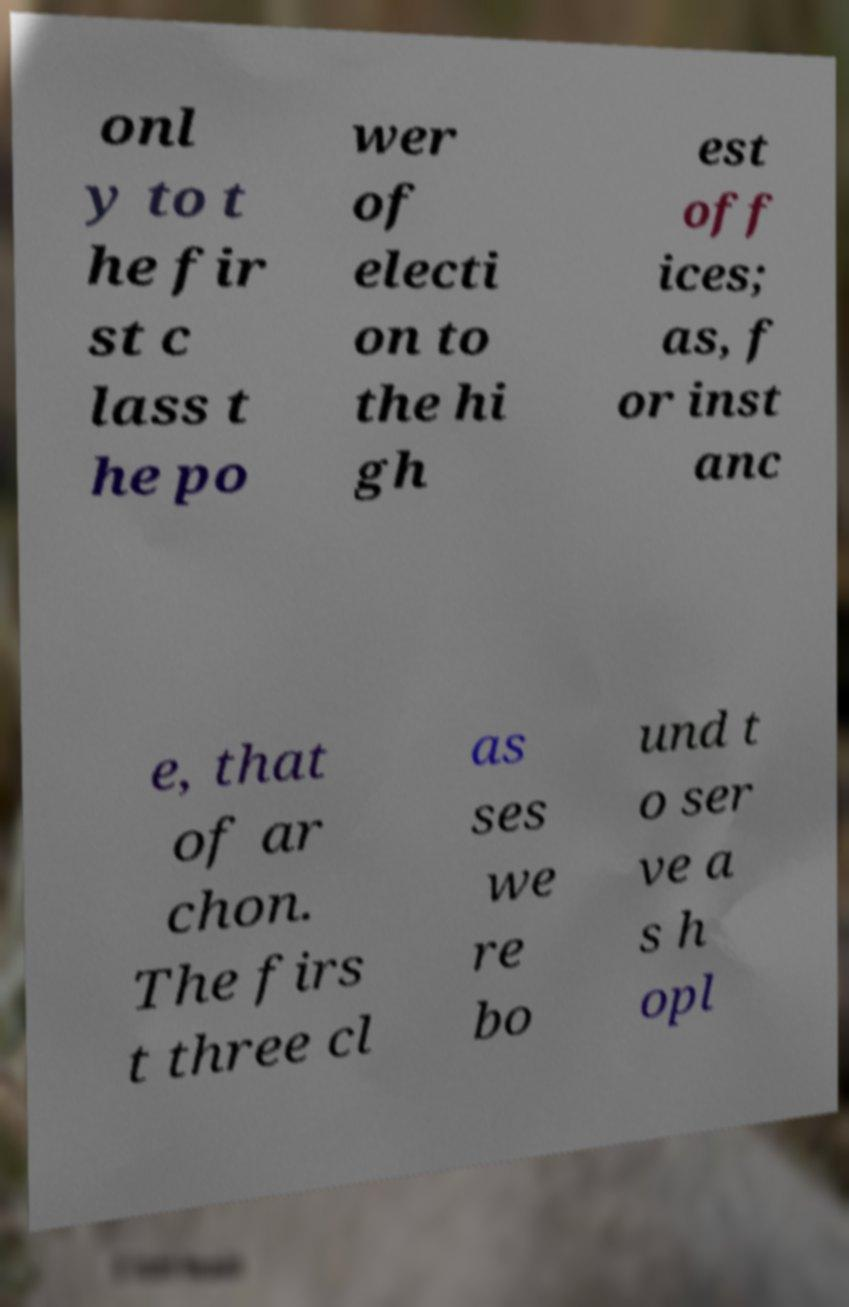For documentation purposes, I need the text within this image transcribed. Could you provide that? onl y to t he fir st c lass t he po wer of electi on to the hi gh est off ices; as, f or inst anc e, that of ar chon. The firs t three cl as ses we re bo und t o ser ve a s h opl 